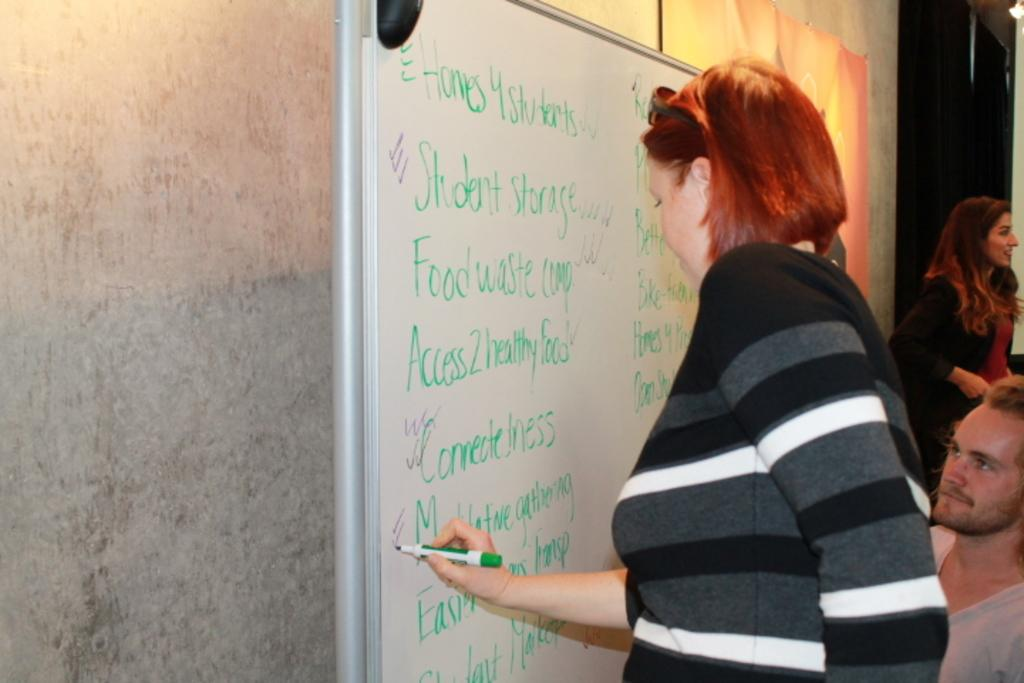<image>
Render a clear and concise summary of the photo. A women with red hair writing on a white board that says Homes 4 students on the top. 